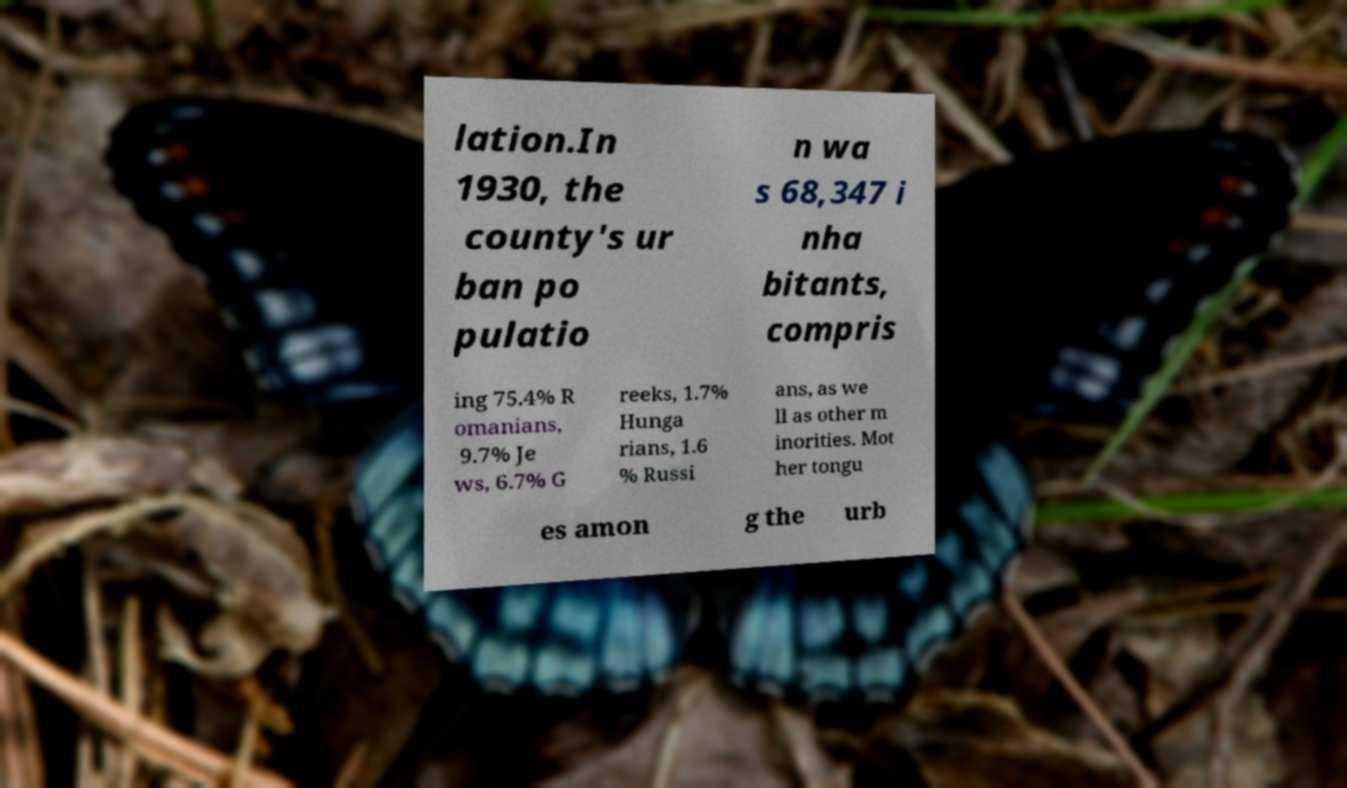What messages or text are displayed in this image? I need them in a readable, typed format. lation.In 1930, the county's ur ban po pulatio n wa s 68,347 i nha bitants, compris ing 75.4% R omanians, 9.7% Je ws, 6.7% G reeks, 1.7% Hunga rians, 1.6 % Russi ans, as we ll as other m inorities. Mot her tongu es amon g the urb 